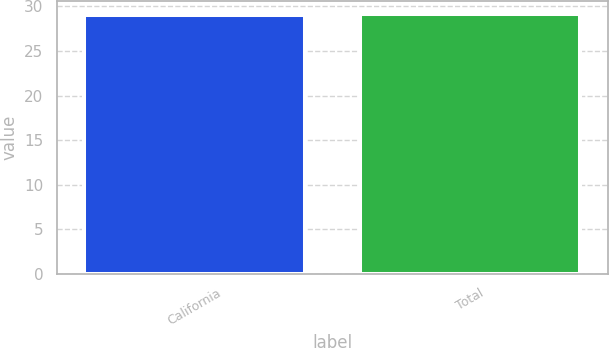<chart> <loc_0><loc_0><loc_500><loc_500><bar_chart><fcel>California<fcel>Total<nl><fcel>29<fcel>29.1<nl></chart> 